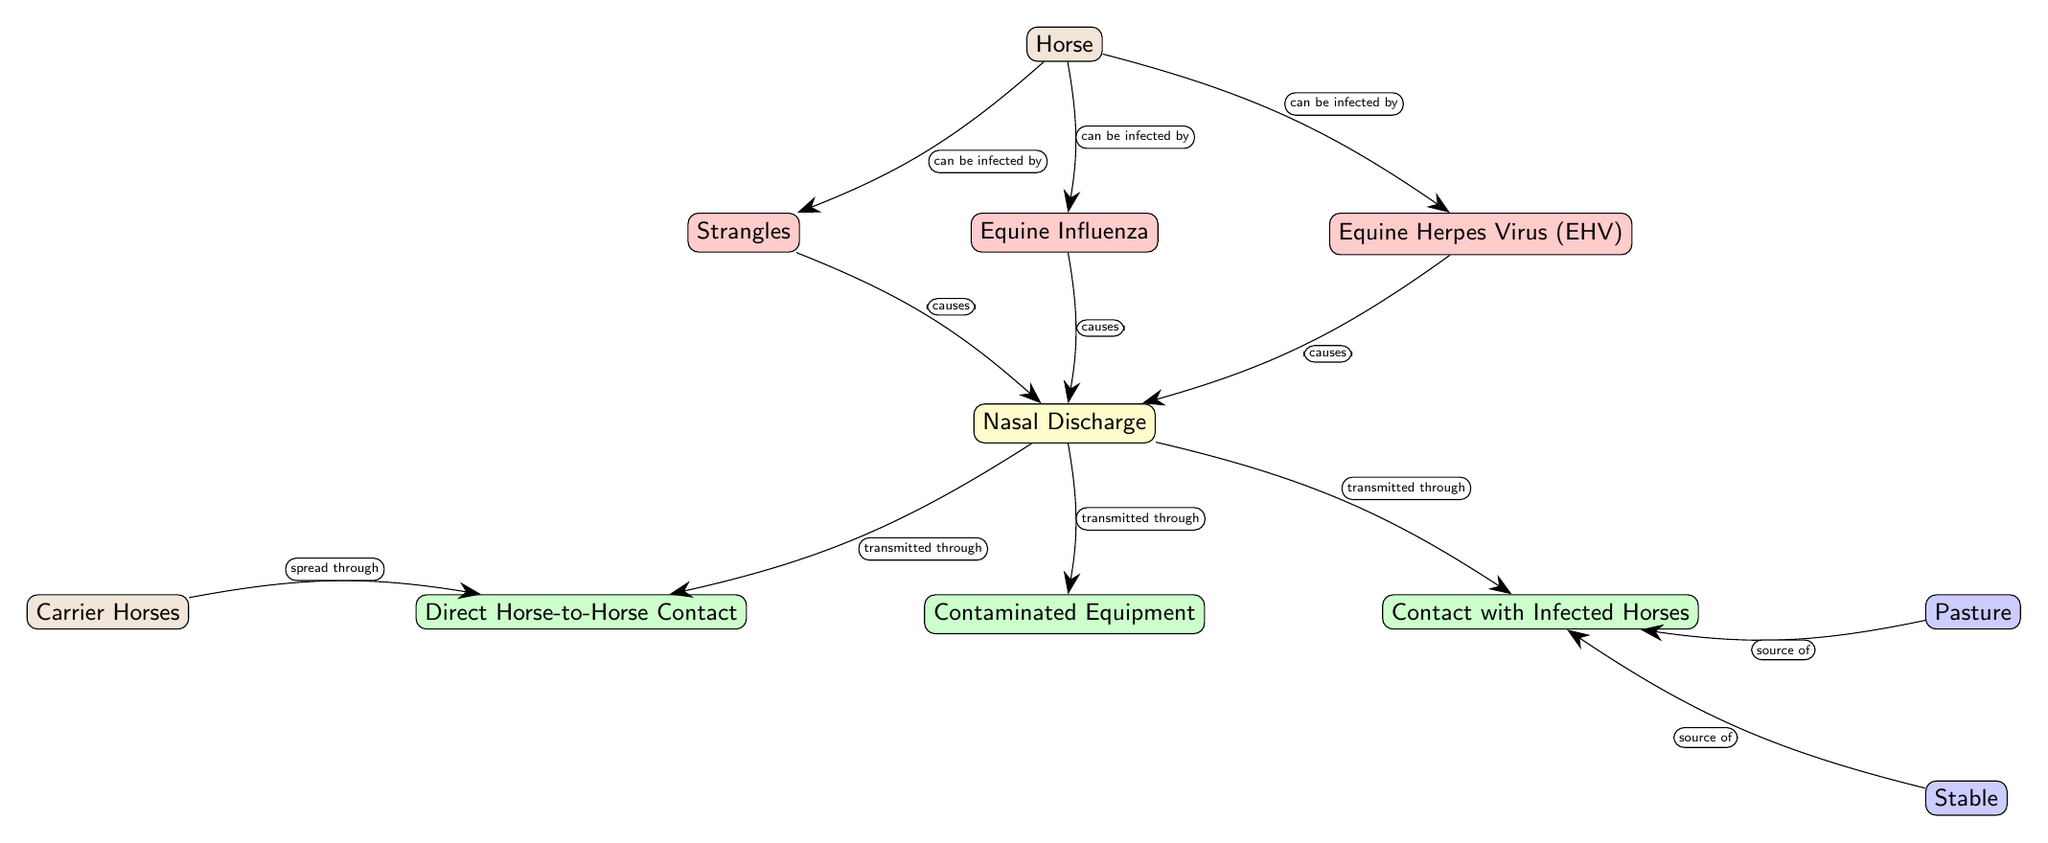What diseases can a horse be infected by? The diagram indicates that a horse can be infected by three diseases: Strangles, Equine Influenza, and Equine Herpes Virus (EHV). These diseases are directly connected to the Horse node as outcome options.
Answer: Strangles, Equine Influenza, Equine Herpes Virus (EHV) How many transmission pathways are shown? There are three transmission pathways indicated in the diagram which are Direct Horse-to-Horse Contact, Contaminated Equipment, and Contact with Infected Horses. They are linked to the Nasal Discharge node, which serves as a point of transmission for the diseases.
Answer: 3 Which symptom is caused by all three diseases? The diagram connects the symptoms of all three diseases to the common result of Nasal Discharge. This means that no matter which disease a horse has, the symptom that presents is Nasal Discharge.
Answer: Nasal Discharge Where do infected horses contact each other? According to the diagram, infected horses can contact each other in the Pasture and the Stable. These locations are shown as sources for the transmission pathway called Contact with Infected Horses.
Answer: Pasture, Stable What is the relationship between Carrier Horses and Direct Horse-to-Horse Contact? The diagram indicates that Carrier Horses spread the infection through Direct Horse-to-Horse Contact. The arrow points from Carrier Horses to the transmission pathway, showing the role of carriers in spreading the disease.
Answer: Spread through How is Nasal Discharge transmitted? The diagram specifies three ways in which Nasal Discharge can be transmitted: through Direct Horse-to-Horse Contact, through Contaminated Equipment, and through Contact with Infected Horses. All these pathways are visually connected to the Nasal Discharge node.
Answer: Direct Horse-to-Horse Contact, Contaminated Equipment, Contact with Infected Horses What is the source of Contact with Infected Horses? The diagram shows that Contact with Infected Horses originates from the environment, specifically from the Pasture and the Stable. These nodes are directly linked as sources to this transmission pathway.
Answer: Pasture, Stable How many diseases result in Nasal Discharge? The diagram illustrates that three diseases result in the symptom Nasal Discharge: Strangles, Equine Influenza, and Equine Herpes Virus (EHV). Each disease is linked to the Nasal Discharge node, indicating their outcome.
Answer: 3 